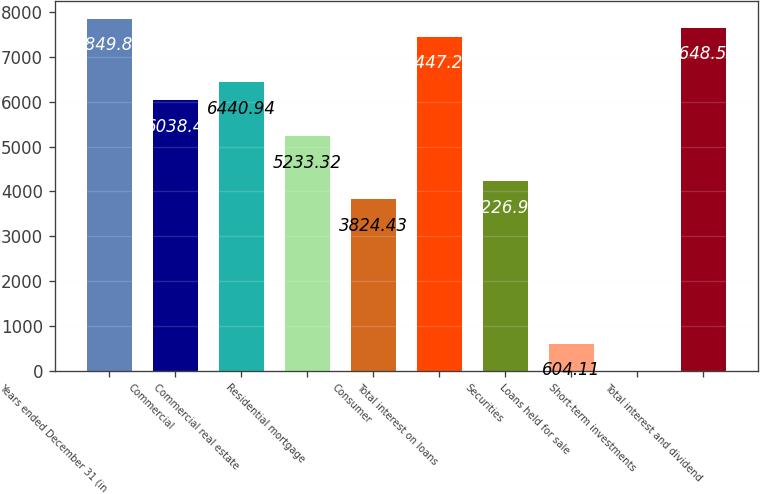Convert chart. <chart><loc_0><loc_0><loc_500><loc_500><bar_chart><fcel>Years ended December 31 (in<fcel>Commercial<fcel>Commercial real estate<fcel>Residential mortgage<fcel>Consumer<fcel>Total interest on loans<fcel>Securities<fcel>Loans held for sale<fcel>Short-term investments<fcel>Total interest and dividend<nl><fcel>7849.83<fcel>6038.4<fcel>6440.94<fcel>5233.32<fcel>3824.43<fcel>7447.29<fcel>4226.97<fcel>604.11<fcel>0.3<fcel>7648.56<nl></chart> 